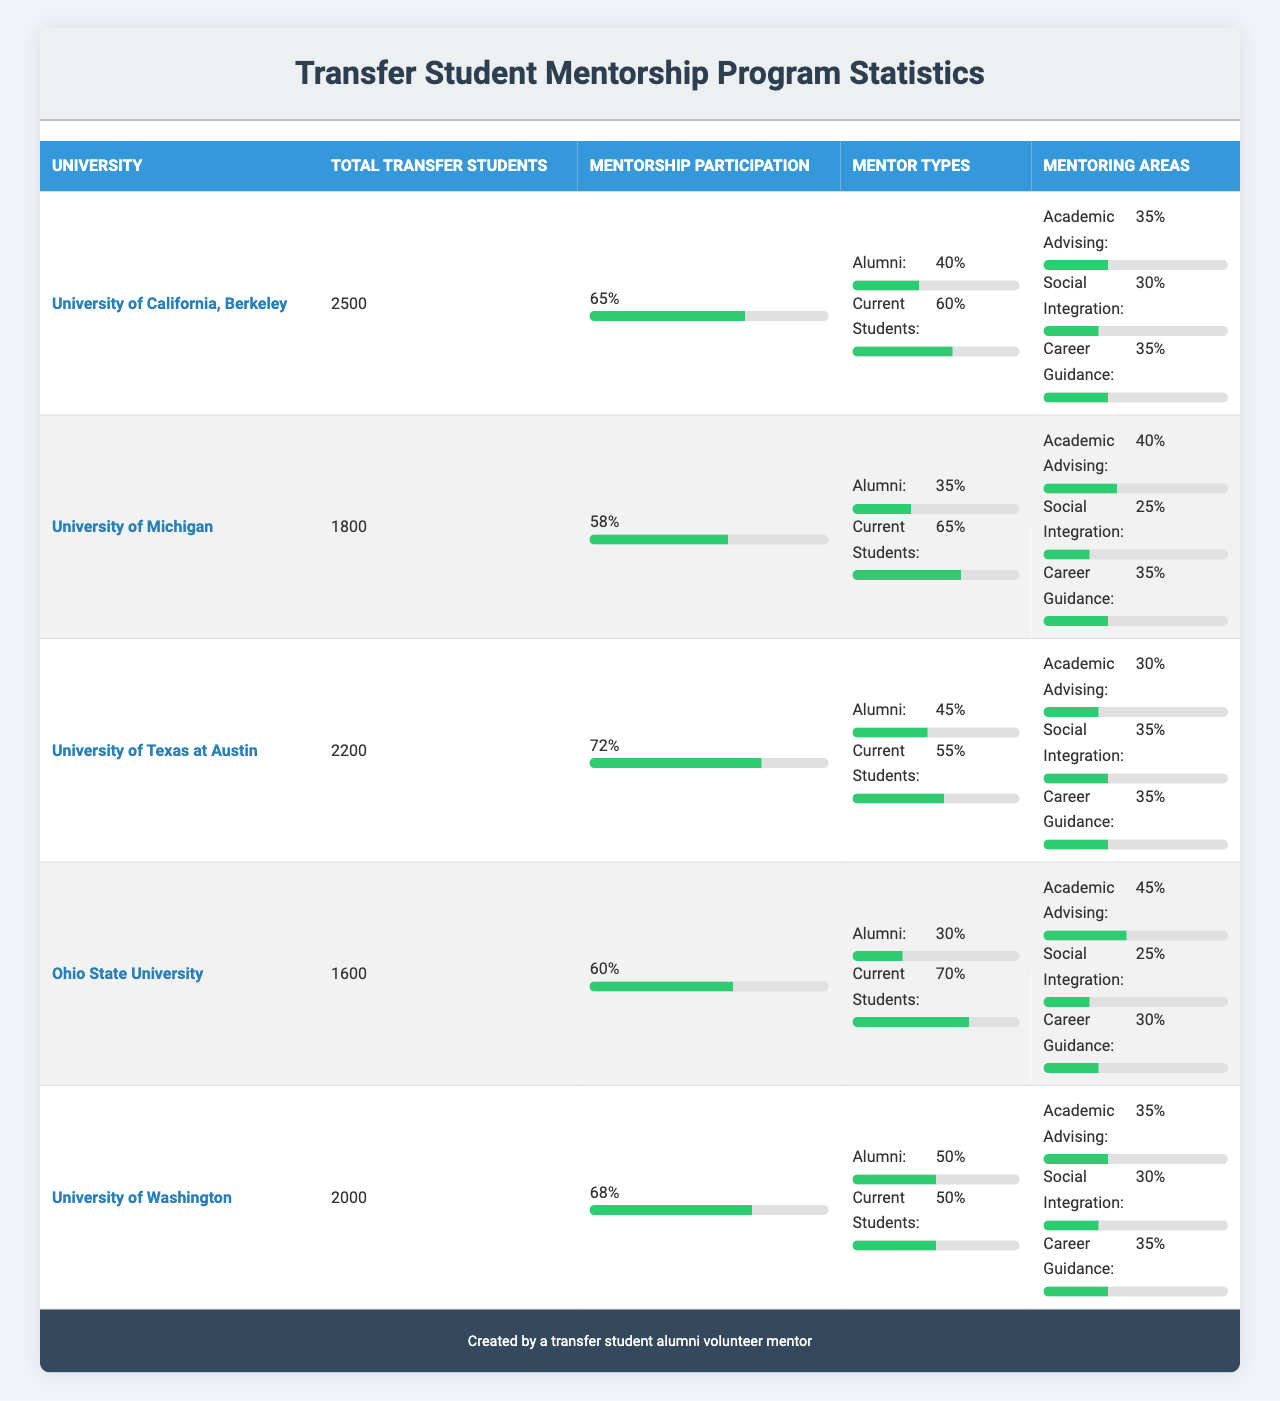What is the total number of transfer students at the University of Texas at Austin? The table lists the total transfer students for each university, and for the University of Texas at Austin, it shows 2200.
Answer: 2200 Which university has the highest mentorship program participation percentage? Looking through the participation percentages, the University of Texas at Austin has the highest percentage at 72%.
Answer: 72% How many universities have a mentorship program participation rate above 65%? The participation rates of the universities are 65%, 58%, 72%, 60%, and 68%. Only the University of Texas at Austin (72%), and the University of Washington (68%) have rates above 65%, which totals 3 universities including UC Berkeley.
Answer: 3 What is the percentage of current students as mentors at Ohio State University? In the table under Ohio State University’s mentorship program, the current student mentor percentage is listed as 70%.
Answer: 70% What areas do mentors at the University of Michigan focus on, and what percentage do they allocate to each? The mentoring areas and their percentages for University of Michigan are: Academic Advising 40%, Social Integration 25%, and Career Guidance 35%.
Answer: Academic Advising 40%, Social Integration 25%, Career Guidance 35% Which type of mentor has a higher percentage at the University of California, Berkeley, current students or alumni? At UC Berkeley, alumni make up 40% while current students comprise 60%, indicating that current students are the higher percentage.
Answer: Current students Calculate the average mentorship participation rate across all universities listed. Adding the participation rates (65+58+72+60+68) equals 323. Dividing by the number of universities (5) gives an average of 64.6.
Answer: 64.6 Is there a university where the percentage of alumni mentors is greater than current student mentors? At University of Texas at Austin, the alumni percentage is 45% while current students are 55%, and it is the only university with typically equal distribution of mentors and no university with alumni more. Therefore, the answer is no.
Answer: No Which university provides the least mentorship in the area of social integration? The percentages for social integration are as follows: UC Berkeley 30%, Michigan 25%, Texas at Austin 35%, Ohio State 25%, and Washington 30%. Both Ohio State University and Michigan provide the least at 25%.
Answer: Ohio State University and University of Michigan How does the academic advising percentage compare between the University of Washington and the University of Michigan? The academic advising percentage for the University of Washington is 35%, while for the University of Michigan it is 40%. Michigan has a higher percentage for academic advising.
Answer: University of Michigan has a higher percentage 